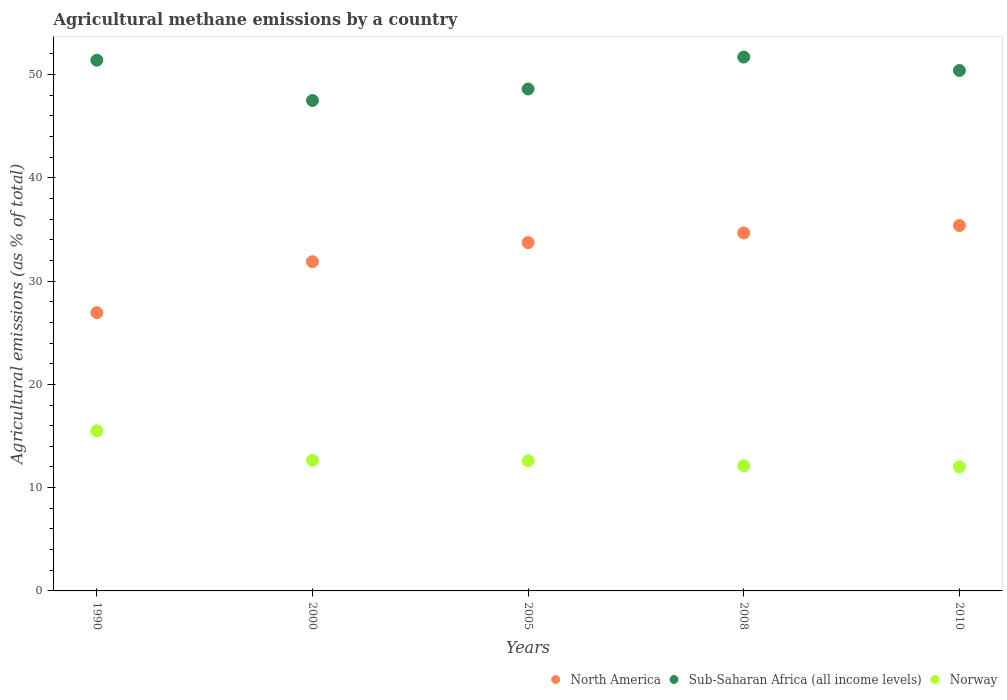How many different coloured dotlines are there?
Your response must be concise. 3. Is the number of dotlines equal to the number of legend labels?
Offer a terse response. Yes. What is the amount of agricultural methane emitted in North America in 2008?
Offer a terse response. 34.66. Across all years, what is the maximum amount of agricultural methane emitted in Sub-Saharan Africa (all income levels)?
Ensure brevity in your answer.  51.69. Across all years, what is the minimum amount of agricultural methane emitted in North America?
Provide a short and direct response. 26.95. In which year was the amount of agricultural methane emitted in North America maximum?
Your response must be concise. 2010. In which year was the amount of agricultural methane emitted in Norway minimum?
Your response must be concise. 2010. What is the total amount of agricultural methane emitted in North America in the graph?
Your answer should be compact. 162.59. What is the difference between the amount of agricultural methane emitted in Sub-Saharan Africa (all income levels) in 2005 and that in 2010?
Your answer should be compact. -1.79. What is the difference between the amount of agricultural methane emitted in Sub-Saharan Africa (all income levels) in 1990 and the amount of agricultural methane emitted in North America in 2000?
Provide a short and direct response. 19.51. What is the average amount of agricultural methane emitted in Sub-Saharan Africa (all income levels) per year?
Give a very brief answer. 49.91. In the year 2000, what is the difference between the amount of agricultural methane emitted in Norway and amount of agricultural methane emitted in North America?
Ensure brevity in your answer.  -19.24. In how many years, is the amount of agricultural methane emitted in Norway greater than 48 %?
Your response must be concise. 0. What is the ratio of the amount of agricultural methane emitted in Norway in 2000 to that in 2010?
Your response must be concise. 1.05. Is the difference between the amount of agricultural methane emitted in Norway in 2005 and 2010 greater than the difference between the amount of agricultural methane emitted in North America in 2005 and 2010?
Provide a succinct answer. Yes. What is the difference between the highest and the second highest amount of agricultural methane emitted in North America?
Give a very brief answer. 0.72. What is the difference between the highest and the lowest amount of agricultural methane emitted in Norway?
Keep it short and to the point. 3.48. Is the sum of the amount of agricultural methane emitted in North America in 2005 and 2008 greater than the maximum amount of agricultural methane emitted in Sub-Saharan Africa (all income levels) across all years?
Your answer should be very brief. Yes. Is it the case that in every year, the sum of the amount of agricultural methane emitted in North America and amount of agricultural methane emitted in Sub-Saharan Africa (all income levels)  is greater than the amount of agricultural methane emitted in Norway?
Provide a short and direct response. Yes. Does the amount of agricultural methane emitted in Norway monotonically increase over the years?
Ensure brevity in your answer.  No. Is the amount of agricultural methane emitted in Sub-Saharan Africa (all income levels) strictly greater than the amount of agricultural methane emitted in North America over the years?
Ensure brevity in your answer.  Yes. How many dotlines are there?
Make the answer very short. 3. How many years are there in the graph?
Offer a terse response. 5. What is the difference between two consecutive major ticks on the Y-axis?
Provide a succinct answer. 10. Does the graph contain any zero values?
Keep it short and to the point. No. What is the title of the graph?
Provide a succinct answer. Agricultural methane emissions by a country. Does "Ethiopia" appear as one of the legend labels in the graph?
Your answer should be compact. No. What is the label or title of the Y-axis?
Provide a succinct answer. Agricultural emissions (as % of total). What is the Agricultural emissions (as % of total) of North America in 1990?
Your answer should be very brief. 26.95. What is the Agricultural emissions (as % of total) in Sub-Saharan Africa (all income levels) in 1990?
Give a very brief answer. 51.39. What is the Agricultural emissions (as % of total) in Norway in 1990?
Provide a succinct answer. 15.5. What is the Agricultural emissions (as % of total) of North America in 2000?
Keep it short and to the point. 31.88. What is the Agricultural emissions (as % of total) in Sub-Saharan Africa (all income levels) in 2000?
Ensure brevity in your answer.  47.48. What is the Agricultural emissions (as % of total) of Norway in 2000?
Provide a short and direct response. 12.64. What is the Agricultural emissions (as % of total) in North America in 2005?
Your response must be concise. 33.73. What is the Agricultural emissions (as % of total) of Sub-Saharan Africa (all income levels) in 2005?
Give a very brief answer. 48.6. What is the Agricultural emissions (as % of total) of Norway in 2005?
Make the answer very short. 12.6. What is the Agricultural emissions (as % of total) in North America in 2008?
Ensure brevity in your answer.  34.66. What is the Agricultural emissions (as % of total) in Sub-Saharan Africa (all income levels) in 2008?
Provide a short and direct response. 51.69. What is the Agricultural emissions (as % of total) in Norway in 2008?
Provide a short and direct response. 12.12. What is the Agricultural emissions (as % of total) of North America in 2010?
Offer a terse response. 35.38. What is the Agricultural emissions (as % of total) of Sub-Saharan Africa (all income levels) in 2010?
Your response must be concise. 50.39. What is the Agricultural emissions (as % of total) in Norway in 2010?
Provide a succinct answer. 12.02. Across all years, what is the maximum Agricultural emissions (as % of total) in North America?
Your response must be concise. 35.38. Across all years, what is the maximum Agricultural emissions (as % of total) of Sub-Saharan Africa (all income levels)?
Provide a succinct answer. 51.69. Across all years, what is the maximum Agricultural emissions (as % of total) in Norway?
Ensure brevity in your answer.  15.5. Across all years, what is the minimum Agricultural emissions (as % of total) in North America?
Your response must be concise. 26.95. Across all years, what is the minimum Agricultural emissions (as % of total) of Sub-Saharan Africa (all income levels)?
Keep it short and to the point. 47.48. Across all years, what is the minimum Agricultural emissions (as % of total) of Norway?
Ensure brevity in your answer.  12.02. What is the total Agricultural emissions (as % of total) of North America in the graph?
Give a very brief answer. 162.59. What is the total Agricultural emissions (as % of total) of Sub-Saharan Africa (all income levels) in the graph?
Give a very brief answer. 249.55. What is the total Agricultural emissions (as % of total) in Norway in the graph?
Keep it short and to the point. 64.87. What is the difference between the Agricultural emissions (as % of total) in North America in 1990 and that in 2000?
Give a very brief answer. -4.93. What is the difference between the Agricultural emissions (as % of total) in Sub-Saharan Africa (all income levels) in 1990 and that in 2000?
Provide a succinct answer. 3.9. What is the difference between the Agricultural emissions (as % of total) in Norway in 1990 and that in 2000?
Your answer should be compact. 2.86. What is the difference between the Agricultural emissions (as % of total) in North America in 1990 and that in 2005?
Offer a very short reply. -6.78. What is the difference between the Agricultural emissions (as % of total) of Sub-Saharan Africa (all income levels) in 1990 and that in 2005?
Offer a terse response. 2.79. What is the difference between the Agricultural emissions (as % of total) of Norway in 1990 and that in 2005?
Give a very brief answer. 2.9. What is the difference between the Agricultural emissions (as % of total) in North America in 1990 and that in 2008?
Provide a short and direct response. -7.71. What is the difference between the Agricultural emissions (as % of total) of Sub-Saharan Africa (all income levels) in 1990 and that in 2008?
Give a very brief answer. -0.3. What is the difference between the Agricultural emissions (as % of total) of Norway in 1990 and that in 2008?
Keep it short and to the point. 3.38. What is the difference between the Agricultural emissions (as % of total) of North America in 1990 and that in 2010?
Give a very brief answer. -8.44. What is the difference between the Agricultural emissions (as % of total) of Sub-Saharan Africa (all income levels) in 1990 and that in 2010?
Offer a very short reply. 1. What is the difference between the Agricultural emissions (as % of total) in Norway in 1990 and that in 2010?
Keep it short and to the point. 3.48. What is the difference between the Agricultural emissions (as % of total) of North America in 2000 and that in 2005?
Offer a terse response. -1.85. What is the difference between the Agricultural emissions (as % of total) of Sub-Saharan Africa (all income levels) in 2000 and that in 2005?
Keep it short and to the point. -1.12. What is the difference between the Agricultural emissions (as % of total) of Norway in 2000 and that in 2005?
Provide a short and direct response. 0.04. What is the difference between the Agricultural emissions (as % of total) of North America in 2000 and that in 2008?
Offer a terse response. -2.78. What is the difference between the Agricultural emissions (as % of total) in Sub-Saharan Africa (all income levels) in 2000 and that in 2008?
Provide a succinct answer. -4.21. What is the difference between the Agricultural emissions (as % of total) in Norway in 2000 and that in 2008?
Your response must be concise. 0.52. What is the difference between the Agricultural emissions (as % of total) in North America in 2000 and that in 2010?
Your answer should be very brief. -3.51. What is the difference between the Agricultural emissions (as % of total) in Sub-Saharan Africa (all income levels) in 2000 and that in 2010?
Your answer should be compact. -2.91. What is the difference between the Agricultural emissions (as % of total) of Norway in 2000 and that in 2010?
Your answer should be compact. 0.62. What is the difference between the Agricultural emissions (as % of total) of North America in 2005 and that in 2008?
Make the answer very short. -0.93. What is the difference between the Agricultural emissions (as % of total) of Sub-Saharan Africa (all income levels) in 2005 and that in 2008?
Provide a succinct answer. -3.09. What is the difference between the Agricultural emissions (as % of total) of Norway in 2005 and that in 2008?
Make the answer very short. 0.48. What is the difference between the Agricultural emissions (as % of total) of North America in 2005 and that in 2010?
Keep it short and to the point. -1.65. What is the difference between the Agricultural emissions (as % of total) in Sub-Saharan Africa (all income levels) in 2005 and that in 2010?
Your response must be concise. -1.79. What is the difference between the Agricultural emissions (as % of total) in Norway in 2005 and that in 2010?
Keep it short and to the point. 0.58. What is the difference between the Agricultural emissions (as % of total) of North America in 2008 and that in 2010?
Offer a very short reply. -0.72. What is the difference between the Agricultural emissions (as % of total) in Sub-Saharan Africa (all income levels) in 2008 and that in 2010?
Offer a very short reply. 1.3. What is the difference between the Agricultural emissions (as % of total) in Norway in 2008 and that in 2010?
Give a very brief answer. 0.1. What is the difference between the Agricultural emissions (as % of total) in North America in 1990 and the Agricultural emissions (as % of total) in Sub-Saharan Africa (all income levels) in 2000?
Offer a terse response. -20.54. What is the difference between the Agricultural emissions (as % of total) of North America in 1990 and the Agricultural emissions (as % of total) of Norway in 2000?
Your answer should be very brief. 14.31. What is the difference between the Agricultural emissions (as % of total) in Sub-Saharan Africa (all income levels) in 1990 and the Agricultural emissions (as % of total) in Norway in 2000?
Offer a terse response. 38.75. What is the difference between the Agricultural emissions (as % of total) of North America in 1990 and the Agricultural emissions (as % of total) of Sub-Saharan Africa (all income levels) in 2005?
Keep it short and to the point. -21.65. What is the difference between the Agricultural emissions (as % of total) in North America in 1990 and the Agricultural emissions (as % of total) in Norway in 2005?
Offer a terse response. 14.35. What is the difference between the Agricultural emissions (as % of total) in Sub-Saharan Africa (all income levels) in 1990 and the Agricultural emissions (as % of total) in Norway in 2005?
Provide a succinct answer. 38.79. What is the difference between the Agricultural emissions (as % of total) in North America in 1990 and the Agricultural emissions (as % of total) in Sub-Saharan Africa (all income levels) in 2008?
Your answer should be compact. -24.74. What is the difference between the Agricultural emissions (as % of total) in North America in 1990 and the Agricultural emissions (as % of total) in Norway in 2008?
Provide a short and direct response. 14.83. What is the difference between the Agricultural emissions (as % of total) of Sub-Saharan Africa (all income levels) in 1990 and the Agricultural emissions (as % of total) of Norway in 2008?
Offer a terse response. 39.27. What is the difference between the Agricultural emissions (as % of total) in North America in 1990 and the Agricultural emissions (as % of total) in Sub-Saharan Africa (all income levels) in 2010?
Your response must be concise. -23.45. What is the difference between the Agricultural emissions (as % of total) of North America in 1990 and the Agricultural emissions (as % of total) of Norway in 2010?
Your response must be concise. 14.93. What is the difference between the Agricultural emissions (as % of total) of Sub-Saharan Africa (all income levels) in 1990 and the Agricultural emissions (as % of total) of Norway in 2010?
Keep it short and to the point. 39.37. What is the difference between the Agricultural emissions (as % of total) in North America in 2000 and the Agricultural emissions (as % of total) in Sub-Saharan Africa (all income levels) in 2005?
Offer a terse response. -16.72. What is the difference between the Agricultural emissions (as % of total) of North America in 2000 and the Agricultural emissions (as % of total) of Norway in 2005?
Offer a terse response. 19.28. What is the difference between the Agricultural emissions (as % of total) of Sub-Saharan Africa (all income levels) in 2000 and the Agricultural emissions (as % of total) of Norway in 2005?
Your answer should be compact. 34.89. What is the difference between the Agricultural emissions (as % of total) in North America in 2000 and the Agricultural emissions (as % of total) in Sub-Saharan Africa (all income levels) in 2008?
Give a very brief answer. -19.81. What is the difference between the Agricultural emissions (as % of total) of North America in 2000 and the Agricultural emissions (as % of total) of Norway in 2008?
Make the answer very short. 19.76. What is the difference between the Agricultural emissions (as % of total) in Sub-Saharan Africa (all income levels) in 2000 and the Agricultural emissions (as % of total) in Norway in 2008?
Offer a terse response. 35.36. What is the difference between the Agricultural emissions (as % of total) in North America in 2000 and the Agricultural emissions (as % of total) in Sub-Saharan Africa (all income levels) in 2010?
Offer a terse response. -18.52. What is the difference between the Agricultural emissions (as % of total) in North America in 2000 and the Agricultural emissions (as % of total) in Norway in 2010?
Ensure brevity in your answer.  19.86. What is the difference between the Agricultural emissions (as % of total) of Sub-Saharan Africa (all income levels) in 2000 and the Agricultural emissions (as % of total) of Norway in 2010?
Give a very brief answer. 35.47. What is the difference between the Agricultural emissions (as % of total) of North America in 2005 and the Agricultural emissions (as % of total) of Sub-Saharan Africa (all income levels) in 2008?
Offer a very short reply. -17.96. What is the difference between the Agricultural emissions (as % of total) of North America in 2005 and the Agricultural emissions (as % of total) of Norway in 2008?
Ensure brevity in your answer.  21.61. What is the difference between the Agricultural emissions (as % of total) of Sub-Saharan Africa (all income levels) in 2005 and the Agricultural emissions (as % of total) of Norway in 2008?
Keep it short and to the point. 36.48. What is the difference between the Agricultural emissions (as % of total) in North America in 2005 and the Agricultural emissions (as % of total) in Sub-Saharan Africa (all income levels) in 2010?
Keep it short and to the point. -16.66. What is the difference between the Agricultural emissions (as % of total) in North America in 2005 and the Agricultural emissions (as % of total) in Norway in 2010?
Offer a very short reply. 21.71. What is the difference between the Agricultural emissions (as % of total) of Sub-Saharan Africa (all income levels) in 2005 and the Agricultural emissions (as % of total) of Norway in 2010?
Provide a short and direct response. 36.58. What is the difference between the Agricultural emissions (as % of total) of North America in 2008 and the Agricultural emissions (as % of total) of Sub-Saharan Africa (all income levels) in 2010?
Ensure brevity in your answer.  -15.73. What is the difference between the Agricultural emissions (as % of total) of North America in 2008 and the Agricultural emissions (as % of total) of Norway in 2010?
Make the answer very short. 22.64. What is the difference between the Agricultural emissions (as % of total) in Sub-Saharan Africa (all income levels) in 2008 and the Agricultural emissions (as % of total) in Norway in 2010?
Provide a succinct answer. 39.67. What is the average Agricultural emissions (as % of total) in North America per year?
Make the answer very short. 32.52. What is the average Agricultural emissions (as % of total) of Sub-Saharan Africa (all income levels) per year?
Keep it short and to the point. 49.91. What is the average Agricultural emissions (as % of total) in Norway per year?
Your answer should be compact. 12.97. In the year 1990, what is the difference between the Agricultural emissions (as % of total) of North America and Agricultural emissions (as % of total) of Sub-Saharan Africa (all income levels)?
Your response must be concise. -24.44. In the year 1990, what is the difference between the Agricultural emissions (as % of total) of North America and Agricultural emissions (as % of total) of Norway?
Provide a succinct answer. 11.45. In the year 1990, what is the difference between the Agricultural emissions (as % of total) of Sub-Saharan Africa (all income levels) and Agricultural emissions (as % of total) of Norway?
Keep it short and to the point. 35.89. In the year 2000, what is the difference between the Agricultural emissions (as % of total) in North America and Agricultural emissions (as % of total) in Sub-Saharan Africa (all income levels)?
Your response must be concise. -15.61. In the year 2000, what is the difference between the Agricultural emissions (as % of total) in North America and Agricultural emissions (as % of total) in Norway?
Give a very brief answer. 19.24. In the year 2000, what is the difference between the Agricultural emissions (as % of total) in Sub-Saharan Africa (all income levels) and Agricultural emissions (as % of total) in Norway?
Give a very brief answer. 34.84. In the year 2005, what is the difference between the Agricultural emissions (as % of total) in North America and Agricultural emissions (as % of total) in Sub-Saharan Africa (all income levels)?
Offer a terse response. -14.87. In the year 2005, what is the difference between the Agricultural emissions (as % of total) of North America and Agricultural emissions (as % of total) of Norway?
Keep it short and to the point. 21.13. In the year 2005, what is the difference between the Agricultural emissions (as % of total) in Sub-Saharan Africa (all income levels) and Agricultural emissions (as % of total) in Norway?
Your response must be concise. 36. In the year 2008, what is the difference between the Agricultural emissions (as % of total) of North America and Agricultural emissions (as % of total) of Sub-Saharan Africa (all income levels)?
Provide a short and direct response. -17.03. In the year 2008, what is the difference between the Agricultural emissions (as % of total) in North America and Agricultural emissions (as % of total) in Norway?
Your answer should be very brief. 22.54. In the year 2008, what is the difference between the Agricultural emissions (as % of total) of Sub-Saharan Africa (all income levels) and Agricultural emissions (as % of total) of Norway?
Make the answer very short. 39.57. In the year 2010, what is the difference between the Agricultural emissions (as % of total) of North America and Agricultural emissions (as % of total) of Sub-Saharan Africa (all income levels)?
Your answer should be compact. -15.01. In the year 2010, what is the difference between the Agricultural emissions (as % of total) of North America and Agricultural emissions (as % of total) of Norway?
Your answer should be compact. 23.37. In the year 2010, what is the difference between the Agricultural emissions (as % of total) of Sub-Saharan Africa (all income levels) and Agricultural emissions (as % of total) of Norway?
Your answer should be compact. 38.38. What is the ratio of the Agricultural emissions (as % of total) of North America in 1990 to that in 2000?
Offer a terse response. 0.85. What is the ratio of the Agricultural emissions (as % of total) of Sub-Saharan Africa (all income levels) in 1990 to that in 2000?
Provide a short and direct response. 1.08. What is the ratio of the Agricultural emissions (as % of total) of Norway in 1990 to that in 2000?
Provide a succinct answer. 1.23. What is the ratio of the Agricultural emissions (as % of total) of North America in 1990 to that in 2005?
Provide a short and direct response. 0.8. What is the ratio of the Agricultural emissions (as % of total) of Sub-Saharan Africa (all income levels) in 1990 to that in 2005?
Keep it short and to the point. 1.06. What is the ratio of the Agricultural emissions (as % of total) in Norway in 1990 to that in 2005?
Keep it short and to the point. 1.23. What is the ratio of the Agricultural emissions (as % of total) in North America in 1990 to that in 2008?
Your response must be concise. 0.78. What is the ratio of the Agricultural emissions (as % of total) of Norway in 1990 to that in 2008?
Your answer should be compact. 1.28. What is the ratio of the Agricultural emissions (as % of total) in North America in 1990 to that in 2010?
Your answer should be compact. 0.76. What is the ratio of the Agricultural emissions (as % of total) in Sub-Saharan Africa (all income levels) in 1990 to that in 2010?
Offer a very short reply. 1.02. What is the ratio of the Agricultural emissions (as % of total) of Norway in 1990 to that in 2010?
Make the answer very short. 1.29. What is the ratio of the Agricultural emissions (as % of total) of North America in 2000 to that in 2005?
Give a very brief answer. 0.95. What is the ratio of the Agricultural emissions (as % of total) in Sub-Saharan Africa (all income levels) in 2000 to that in 2005?
Your answer should be very brief. 0.98. What is the ratio of the Agricultural emissions (as % of total) in Norway in 2000 to that in 2005?
Give a very brief answer. 1. What is the ratio of the Agricultural emissions (as % of total) in North America in 2000 to that in 2008?
Provide a succinct answer. 0.92. What is the ratio of the Agricultural emissions (as % of total) of Sub-Saharan Africa (all income levels) in 2000 to that in 2008?
Offer a terse response. 0.92. What is the ratio of the Agricultural emissions (as % of total) of Norway in 2000 to that in 2008?
Your response must be concise. 1.04. What is the ratio of the Agricultural emissions (as % of total) of North America in 2000 to that in 2010?
Offer a terse response. 0.9. What is the ratio of the Agricultural emissions (as % of total) of Sub-Saharan Africa (all income levels) in 2000 to that in 2010?
Provide a short and direct response. 0.94. What is the ratio of the Agricultural emissions (as % of total) in Norway in 2000 to that in 2010?
Give a very brief answer. 1.05. What is the ratio of the Agricultural emissions (as % of total) of North America in 2005 to that in 2008?
Keep it short and to the point. 0.97. What is the ratio of the Agricultural emissions (as % of total) in Sub-Saharan Africa (all income levels) in 2005 to that in 2008?
Your answer should be compact. 0.94. What is the ratio of the Agricultural emissions (as % of total) in Norway in 2005 to that in 2008?
Make the answer very short. 1.04. What is the ratio of the Agricultural emissions (as % of total) of North America in 2005 to that in 2010?
Your response must be concise. 0.95. What is the ratio of the Agricultural emissions (as % of total) in Sub-Saharan Africa (all income levels) in 2005 to that in 2010?
Your answer should be compact. 0.96. What is the ratio of the Agricultural emissions (as % of total) of Norway in 2005 to that in 2010?
Provide a short and direct response. 1.05. What is the ratio of the Agricultural emissions (as % of total) of North America in 2008 to that in 2010?
Provide a short and direct response. 0.98. What is the ratio of the Agricultural emissions (as % of total) in Sub-Saharan Africa (all income levels) in 2008 to that in 2010?
Your answer should be compact. 1.03. What is the ratio of the Agricultural emissions (as % of total) of Norway in 2008 to that in 2010?
Give a very brief answer. 1.01. What is the difference between the highest and the second highest Agricultural emissions (as % of total) in North America?
Your answer should be compact. 0.72. What is the difference between the highest and the second highest Agricultural emissions (as % of total) of Sub-Saharan Africa (all income levels)?
Your answer should be very brief. 0.3. What is the difference between the highest and the second highest Agricultural emissions (as % of total) in Norway?
Ensure brevity in your answer.  2.86. What is the difference between the highest and the lowest Agricultural emissions (as % of total) of North America?
Offer a terse response. 8.44. What is the difference between the highest and the lowest Agricultural emissions (as % of total) of Sub-Saharan Africa (all income levels)?
Your answer should be very brief. 4.21. What is the difference between the highest and the lowest Agricultural emissions (as % of total) in Norway?
Provide a short and direct response. 3.48. 